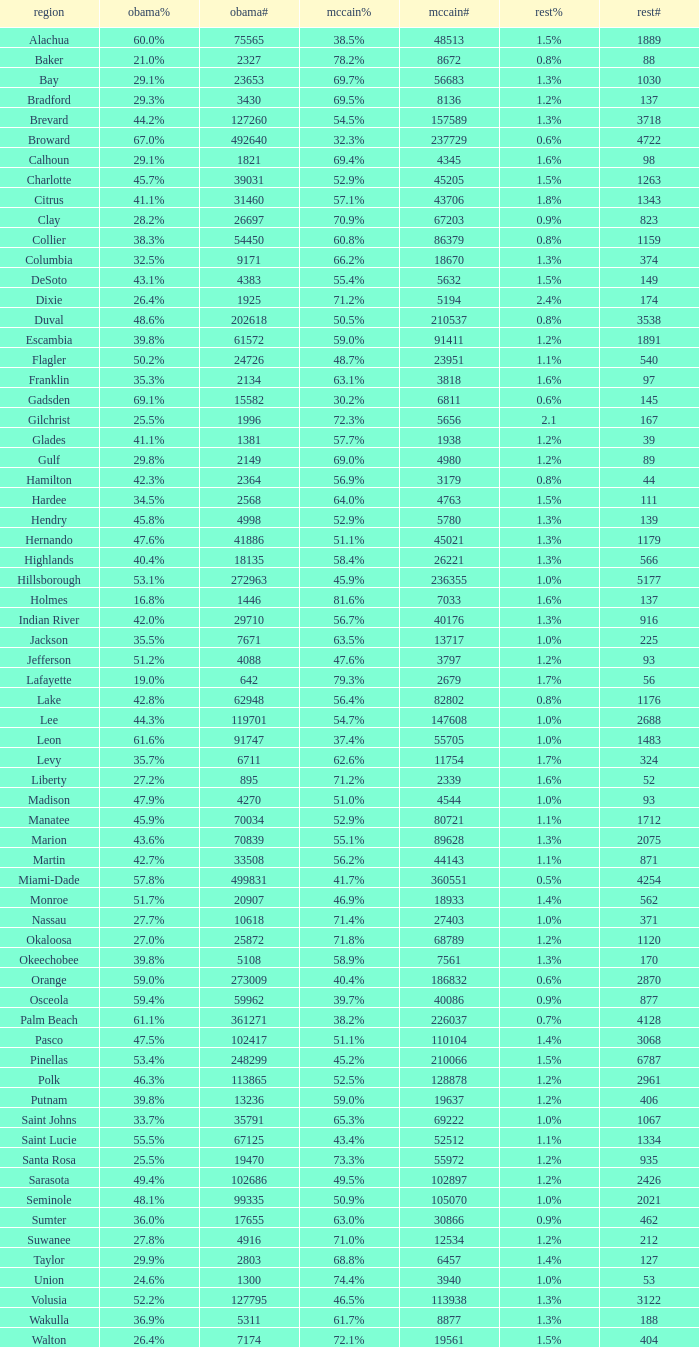What percentage was the others vote when McCain had 52.9% and less than 45205.0 voters? 1.3%. 